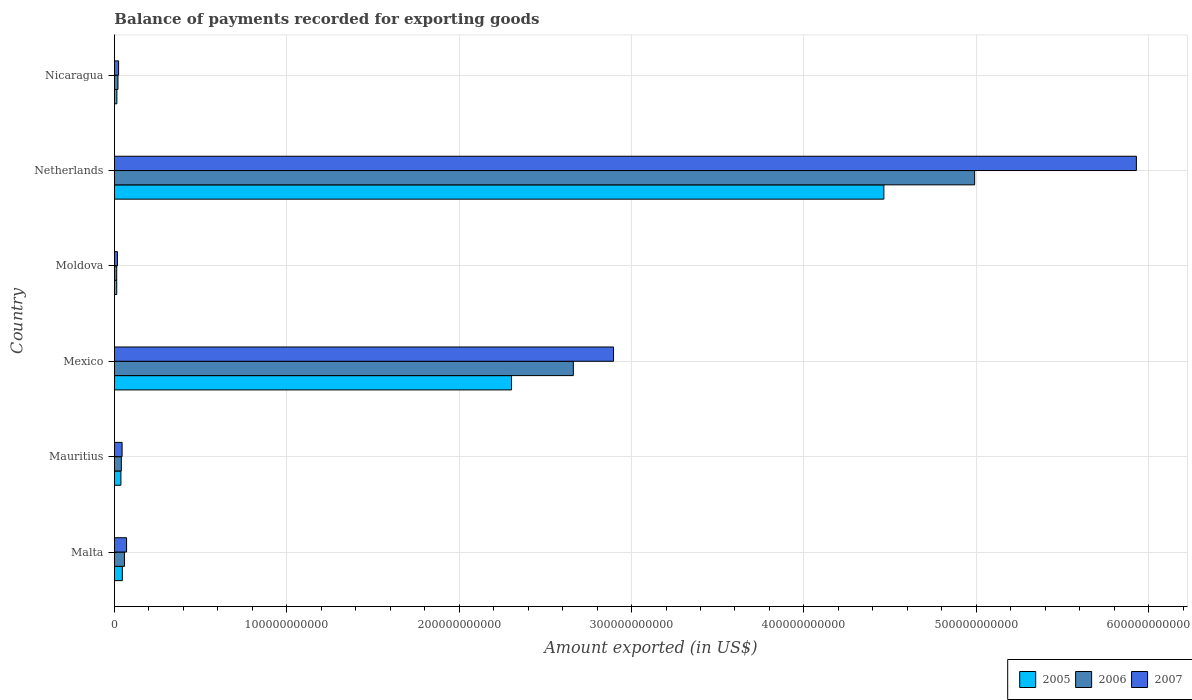How many different coloured bars are there?
Make the answer very short. 3. How many groups of bars are there?
Give a very brief answer. 6. Are the number of bars per tick equal to the number of legend labels?
Make the answer very short. Yes. Are the number of bars on each tick of the Y-axis equal?
Your response must be concise. Yes. How many bars are there on the 5th tick from the bottom?
Provide a short and direct response. 3. What is the label of the 6th group of bars from the top?
Your answer should be very brief. Malta. In how many cases, is the number of bars for a given country not equal to the number of legend labels?
Ensure brevity in your answer.  0. What is the amount exported in 2005 in Moldova?
Your answer should be very brief. 1.33e+09. Across all countries, what is the maximum amount exported in 2007?
Your answer should be compact. 5.93e+11. Across all countries, what is the minimum amount exported in 2007?
Your response must be concise. 1.75e+09. In which country was the amount exported in 2005 maximum?
Provide a succinct answer. Netherlands. In which country was the amount exported in 2007 minimum?
Your answer should be very brief. Moldova. What is the total amount exported in 2005 in the graph?
Your response must be concise. 6.88e+11. What is the difference between the amount exported in 2006 in Malta and that in Mauritius?
Your response must be concise. 1.81e+09. What is the difference between the amount exported in 2006 in Netherlands and the amount exported in 2005 in Malta?
Make the answer very short. 4.94e+11. What is the average amount exported in 2005 per country?
Offer a very short reply. 1.15e+11. What is the difference between the amount exported in 2007 and amount exported in 2006 in Mauritius?
Make the answer very short. 4.43e+08. What is the ratio of the amount exported in 2006 in Malta to that in Moldova?
Your answer should be compact. 4.4. What is the difference between the highest and the second highest amount exported in 2006?
Offer a very short reply. 2.33e+11. What is the difference between the highest and the lowest amount exported in 2005?
Your answer should be very brief. 4.45e+11. How many bars are there?
Provide a succinct answer. 18. What is the difference between two consecutive major ticks on the X-axis?
Your answer should be very brief. 1.00e+11. Does the graph contain grids?
Offer a terse response. Yes. Where does the legend appear in the graph?
Offer a very short reply. Bottom right. How are the legend labels stacked?
Make the answer very short. Horizontal. What is the title of the graph?
Your answer should be compact. Balance of payments recorded for exporting goods. What is the label or title of the X-axis?
Offer a terse response. Amount exported (in US$). What is the Amount exported (in US$) of 2005 in Malta?
Your response must be concise. 4.59e+09. What is the Amount exported (in US$) in 2006 in Malta?
Make the answer very short. 5.81e+09. What is the Amount exported (in US$) of 2007 in Malta?
Provide a succinct answer. 7.05e+09. What is the Amount exported (in US$) in 2005 in Mauritius?
Ensure brevity in your answer.  3.76e+09. What is the Amount exported (in US$) of 2006 in Mauritius?
Your response must be concise. 4.00e+09. What is the Amount exported (in US$) in 2007 in Mauritius?
Keep it short and to the point. 4.44e+09. What is the Amount exported (in US$) in 2005 in Mexico?
Your answer should be very brief. 2.30e+11. What is the Amount exported (in US$) in 2006 in Mexico?
Offer a very short reply. 2.66e+11. What is the Amount exported (in US$) in 2007 in Mexico?
Provide a succinct answer. 2.90e+11. What is the Amount exported (in US$) of 2005 in Moldova?
Provide a short and direct response. 1.33e+09. What is the Amount exported (in US$) in 2006 in Moldova?
Your response must be concise. 1.32e+09. What is the Amount exported (in US$) in 2007 in Moldova?
Offer a very short reply. 1.75e+09. What is the Amount exported (in US$) in 2005 in Netherlands?
Give a very brief answer. 4.46e+11. What is the Amount exported (in US$) of 2006 in Netherlands?
Offer a very short reply. 4.99e+11. What is the Amount exported (in US$) of 2007 in Netherlands?
Your answer should be compact. 5.93e+11. What is the Amount exported (in US$) of 2005 in Nicaragua?
Keep it short and to the point. 1.41e+09. What is the Amount exported (in US$) in 2006 in Nicaragua?
Your answer should be very brief. 2.05e+09. What is the Amount exported (in US$) of 2007 in Nicaragua?
Your answer should be compact. 2.42e+09. Across all countries, what is the maximum Amount exported (in US$) in 2005?
Provide a short and direct response. 4.46e+11. Across all countries, what is the maximum Amount exported (in US$) of 2006?
Your answer should be very brief. 4.99e+11. Across all countries, what is the maximum Amount exported (in US$) of 2007?
Give a very brief answer. 5.93e+11. Across all countries, what is the minimum Amount exported (in US$) of 2005?
Your answer should be compact. 1.33e+09. Across all countries, what is the minimum Amount exported (in US$) of 2006?
Provide a short and direct response. 1.32e+09. Across all countries, what is the minimum Amount exported (in US$) of 2007?
Keep it short and to the point. 1.75e+09. What is the total Amount exported (in US$) in 2005 in the graph?
Keep it short and to the point. 6.88e+11. What is the total Amount exported (in US$) of 2006 in the graph?
Ensure brevity in your answer.  7.78e+11. What is the total Amount exported (in US$) of 2007 in the graph?
Your answer should be compact. 8.98e+11. What is the difference between the Amount exported (in US$) of 2005 in Malta and that in Mauritius?
Offer a terse response. 8.36e+08. What is the difference between the Amount exported (in US$) in 2006 in Malta and that in Mauritius?
Your answer should be very brief. 1.81e+09. What is the difference between the Amount exported (in US$) of 2007 in Malta and that in Mauritius?
Your response must be concise. 2.61e+09. What is the difference between the Amount exported (in US$) of 2005 in Malta and that in Mexico?
Make the answer very short. -2.26e+11. What is the difference between the Amount exported (in US$) in 2006 in Malta and that in Mexico?
Ensure brevity in your answer.  -2.60e+11. What is the difference between the Amount exported (in US$) of 2007 in Malta and that in Mexico?
Your response must be concise. -2.82e+11. What is the difference between the Amount exported (in US$) of 2005 in Malta and that in Moldova?
Make the answer very short. 3.26e+09. What is the difference between the Amount exported (in US$) in 2006 in Malta and that in Moldova?
Give a very brief answer. 4.49e+09. What is the difference between the Amount exported (in US$) in 2007 in Malta and that in Moldova?
Provide a short and direct response. 5.30e+09. What is the difference between the Amount exported (in US$) of 2005 in Malta and that in Netherlands?
Your response must be concise. -4.42e+11. What is the difference between the Amount exported (in US$) of 2006 in Malta and that in Netherlands?
Give a very brief answer. -4.93e+11. What is the difference between the Amount exported (in US$) in 2007 in Malta and that in Netherlands?
Your answer should be very brief. -5.86e+11. What is the difference between the Amount exported (in US$) of 2005 in Malta and that in Nicaragua?
Provide a short and direct response. 3.18e+09. What is the difference between the Amount exported (in US$) in 2006 in Malta and that in Nicaragua?
Give a very brief answer. 3.76e+09. What is the difference between the Amount exported (in US$) in 2007 in Malta and that in Nicaragua?
Your response must be concise. 4.63e+09. What is the difference between the Amount exported (in US$) in 2005 in Mauritius and that in Mexico?
Give a very brief answer. -2.27e+11. What is the difference between the Amount exported (in US$) in 2006 in Mauritius and that in Mexico?
Offer a very short reply. -2.62e+11. What is the difference between the Amount exported (in US$) of 2007 in Mauritius and that in Mexico?
Keep it short and to the point. -2.85e+11. What is the difference between the Amount exported (in US$) of 2005 in Mauritius and that in Moldova?
Offer a very short reply. 2.42e+09. What is the difference between the Amount exported (in US$) of 2006 in Mauritius and that in Moldova?
Ensure brevity in your answer.  2.68e+09. What is the difference between the Amount exported (in US$) of 2007 in Mauritius and that in Moldova?
Offer a very short reply. 2.70e+09. What is the difference between the Amount exported (in US$) of 2005 in Mauritius and that in Netherlands?
Provide a short and direct response. -4.43e+11. What is the difference between the Amount exported (in US$) in 2006 in Mauritius and that in Netherlands?
Give a very brief answer. -4.95e+11. What is the difference between the Amount exported (in US$) of 2007 in Mauritius and that in Netherlands?
Provide a succinct answer. -5.88e+11. What is the difference between the Amount exported (in US$) in 2005 in Mauritius and that in Nicaragua?
Keep it short and to the point. 2.35e+09. What is the difference between the Amount exported (in US$) of 2006 in Mauritius and that in Nicaragua?
Provide a short and direct response. 1.95e+09. What is the difference between the Amount exported (in US$) in 2007 in Mauritius and that in Nicaragua?
Make the answer very short. 2.02e+09. What is the difference between the Amount exported (in US$) in 2005 in Mexico and that in Moldova?
Provide a succinct answer. 2.29e+11. What is the difference between the Amount exported (in US$) of 2006 in Mexico and that in Moldova?
Your response must be concise. 2.65e+11. What is the difference between the Amount exported (in US$) of 2007 in Mexico and that in Moldova?
Provide a succinct answer. 2.88e+11. What is the difference between the Amount exported (in US$) in 2005 in Mexico and that in Netherlands?
Your response must be concise. -2.16e+11. What is the difference between the Amount exported (in US$) in 2006 in Mexico and that in Netherlands?
Your answer should be compact. -2.33e+11. What is the difference between the Amount exported (in US$) of 2007 in Mexico and that in Netherlands?
Keep it short and to the point. -3.03e+11. What is the difference between the Amount exported (in US$) in 2005 in Mexico and that in Nicaragua?
Ensure brevity in your answer.  2.29e+11. What is the difference between the Amount exported (in US$) in 2006 in Mexico and that in Nicaragua?
Keep it short and to the point. 2.64e+11. What is the difference between the Amount exported (in US$) in 2007 in Mexico and that in Nicaragua?
Provide a short and direct response. 2.87e+11. What is the difference between the Amount exported (in US$) of 2005 in Moldova and that in Netherlands?
Ensure brevity in your answer.  -4.45e+11. What is the difference between the Amount exported (in US$) in 2006 in Moldova and that in Netherlands?
Your answer should be compact. -4.98e+11. What is the difference between the Amount exported (in US$) in 2007 in Moldova and that in Netherlands?
Your response must be concise. -5.91e+11. What is the difference between the Amount exported (in US$) in 2005 in Moldova and that in Nicaragua?
Your response must be concise. -7.89e+07. What is the difference between the Amount exported (in US$) of 2006 in Moldova and that in Nicaragua?
Provide a short and direct response. -7.32e+08. What is the difference between the Amount exported (in US$) in 2007 in Moldova and that in Nicaragua?
Your answer should be very brief. -6.74e+08. What is the difference between the Amount exported (in US$) of 2005 in Netherlands and that in Nicaragua?
Keep it short and to the point. 4.45e+11. What is the difference between the Amount exported (in US$) of 2006 in Netherlands and that in Nicaragua?
Your response must be concise. 4.97e+11. What is the difference between the Amount exported (in US$) of 2007 in Netherlands and that in Nicaragua?
Your answer should be compact. 5.90e+11. What is the difference between the Amount exported (in US$) of 2005 in Malta and the Amount exported (in US$) of 2006 in Mauritius?
Your answer should be compact. 5.92e+08. What is the difference between the Amount exported (in US$) in 2005 in Malta and the Amount exported (in US$) in 2007 in Mauritius?
Ensure brevity in your answer.  1.49e+08. What is the difference between the Amount exported (in US$) of 2006 in Malta and the Amount exported (in US$) of 2007 in Mauritius?
Your answer should be very brief. 1.37e+09. What is the difference between the Amount exported (in US$) of 2005 in Malta and the Amount exported (in US$) of 2006 in Mexico?
Your answer should be very brief. -2.62e+11. What is the difference between the Amount exported (in US$) of 2005 in Malta and the Amount exported (in US$) of 2007 in Mexico?
Your answer should be very brief. -2.85e+11. What is the difference between the Amount exported (in US$) of 2006 in Malta and the Amount exported (in US$) of 2007 in Mexico?
Make the answer very short. -2.84e+11. What is the difference between the Amount exported (in US$) of 2005 in Malta and the Amount exported (in US$) of 2006 in Moldova?
Keep it short and to the point. 3.27e+09. What is the difference between the Amount exported (in US$) of 2005 in Malta and the Amount exported (in US$) of 2007 in Moldova?
Your answer should be very brief. 2.85e+09. What is the difference between the Amount exported (in US$) in 2006 in Malta and the Amount exported (in US$) in 2007 in Moldova?
Offer a terse response. 4.07e+09. What is the difference between the Amount exported (in US$) of 2005 in Malta and the Amount exported (in US$) of 2006 in Netherlands?
Provide a succinct answer. -4.94e+11. What is the difference between the Amount exported (in US$) of 2005 in Malta and the Amount exported (in US$) of 2007 in Netherlands?
Make the answer very short. -5.88e+11. What is the difference between the Amount exported (in US$) in 2006 in Malta and the Amount exported (in US$) in 2007 in Netherlands?
Give a very brief answer. -5.87e+11. What is the difference between the Amount exported (in US$) of 2005 in Malta and the Amount exported (in US$) of 2006 in Nicaragua?
Offer a terse response. 2.54e+09. What is the difference between the Amount exported (in US$) in 2005 in Malta and the Amount exported (in US$) in 2007 in Nicaragua?
Give a very brief answer. 2.17e+09. What is the difference between the Amount exported (in US$) in 2006 in Malta and the Amount exported (in US$) in 2007 in Nicaragua?
Ensure brevity in your answer.  3.39e+09. What is the difference between the Amount exported (in US$) of 2005 in Mauritius and the Amount exported (in US$) of 2006 in Mexico?
Offer a terse response. -2.62e+11. What is the difference between the Amount exported (in US$) in 2005 in Mauritius and the Amount exported (in US$) in 2007 in Mexico?
Your answer should be compact. -2.86e+11. What is the difference between the Amount exported (in US$) in 2006 in Mauritius and the Amount exported (in US$) in 2007 in Mexico?
Make the answer very short. -2.86e+11. What is the difference between the Amount exported (in US$) of 2005 in Mauritius and the Amount exported (in US$) of 2006 in Moldova?
Keep it short and to the point. 2.43e+09. What is the difference between the Amount exported (in US$) in 2005 in Mauritius and the Amount exported (in US$) in 2007 in Moldova?
Offer a very short reply. 2.01e+09. What is the difference between the Amount exported (in US$) of 2006 in Mauritius and the Amount exported (in US$) of 2007 in Moldova?
Your response must be concise. 2.25e+09. What is the difference between the Amount exported (in US$) in 2005 in Mauritius and the Amount exported (in US$) in 2006 in Netherlands?
Your answer should be compact. -4.95e+11. What is the difference between the Amount exported (in US$) in 2005 in Mauritius and the Amount exported (in US$) in 2007 in Netherlands?
Make the answer very short. -5.89e+11. What is the difference between the Amount exported (in US$) of 2006 in Mauritius and the Amount exported (in US$) of 2007 in Netherlands?
Give a very brief answer. -5.89e+11. What is the difference between the Amount exported (in US$) of 2005 in Mauritius and the Amount exported (in US$) of 2006 in Nicaragua?
Keep it short and to the point. 1.70e+09. What is the difference between the Amount exported (in US$) of 2005 in Mauritius and the Amount exported (in US$) of 2007 in Nicaragua?
Ensure brevity in your answer.  1.34e+09. What is the difference between the Amount exported (in US$) in 2006 in Mauritius and the Amount exported (in US$) in 2007 in Nicaragua?
Your answer should be very brief. 1.58e+09. What is the difference between the Amount exported (in US$) in 2005 in Mexico and the Amount exported (in US$) in 2006 in Moldova?
Your answer should be compact. 2.29e+11. What is the difference between the Amount exported (in US$) of 2005 in Mexico and the Amount exported (in US$) of 2007 in Moldova?
Offer a very short reply. 2.29e+11. What is the difference between the Amount exported (in US$) of 2006 in Mexico and the Amount exported (in US$) of 2007 in Moldova?
Your response must be concise. 2.64e+11. What is the difference between the Amount exported (in US$) of 2005 in Mexico and the Amount exported (in US$) of 2006 in Netherlands?
Offer a very short reply. -2.69e+11. What is the difference between the Amount exported (in US$) in 2005 in Mexico and the Amount exported (in US$) in 2007 in Netherlands?
Provide a succinct answer. -3.62e+11. What is the difference between the Amount exported (in US$) of 2006 in Mexico and the Amount exported (in US$) of 2007 in Netherlands?
Offer a terse response. -3.27e+11. What is the difference between the Amount exported (in US$) of 2005 in Mexico and the Amount exported (in US$) of 2006 in Nicaragua?
Make the answer very short. 2.28e+11. What is the difference between the Amount exported (in US$) in 2005 in Mexico and the Amount exported (in US$) in 2007 in Nicaragua?
Provide a succinct answer. 2.28e+11. What is the difference between the Amount exported (in US$) in 2006 in Mexico and the Amount exported (in US$) in 2007 in Nicaragua?
Your response must be concise. 2.64e+11. What is the difference between the Amount exported (in US$) of 2005 in Moldova and the Amount exported (in US$) of 2006 in Netherlands?
Your response must be concise. -4.98e+11. What is the difference between the Amount exported (in US$) in 2005 in Moldova and the Amount exported (in US$) in 2007 in Netherlands?
Make the answer very short. -5.92e+11. What is the difference between the Amount exported (in US$) of 2006 in Moldova and the Amount exported (in US$) of 2007 in Netherlands?
Give a very brief answer. -5.92e+11. What is the difference between the Amount exported (in US$) in 2005 in Moldova and the Amount exported (in US$) in 2006 in Nicaragua?
Provide a short and direct response. -7.22e+08. What is the difference between the Amount exported (in US$) in 2005 in Moldova and the Amount exported (in US$) in 2007 in Nicaragua?
Keep it short and to the point. -1.09e+09. What is the difference between the Amount exported (in US$) in 2006 in Moldova and the Amount exported (in US$) in 2007 in Nicaragua?
Give a very brief answer. -1.10e+09. What is the difference between the Amount exported (in US$) in 2005 in Netherlands and the Amount exported (in US$) in 2006 in Nicaragua?
Keep it short and to the point. 4.44e+11. What is the difference between the Amount exported (in US$) in 2005 in Netherlands and the Amount exported (in US$) in 2007 in Nicaragua?
Provide a succinct answer. 4.44e+11. What is the difference between the Amount exported (in US$) of 2006 in Netherlands and the Amount exported (in US$) of 2007 in Nicaragua?
Your answer should be compact. 4.97e+11. What is the average Amount exported (in US$) of 2005 per country?
Your answer should be very brief. 1.15e+11. What is the average Amount exported (in US$) of 2006 per country?
Provide a short and direct response. 1.30e+11. What is the average Amount exported (in US$) in 2007 per country?
Your response must be concise. 1.50e+11. What is the difference between the Amount exported (in US$) of 2005 and Amount exported (in US$) of 2006 in Malta?
Your response must be concise. -1.22e+09. What is the difference between the Amount exported (in US$) of 2005 and Amount exported (in US$) of 2007 in Malta?
Your response must be concise. -2.46e+09. What is the difference between the Amount exported (in US$) in 2006 and Amount exported (in US$) in 2007 in Malta?
Give a very brief answer. -1.24e+09. What is the difference between the Amount exported (in US$) of 2005 and Amount exported (in US$) of 2006 in Mauritius?
Offer a very short reply. -2.44e+08. What is the difference between the Amount exported (in US$) of 2005 and Amount exported (in US$) of 2007 in Mauritius?
Your answer should be very brief. -6.87e+08. What is the difference between the Amount exported (in US$) of 2006 and Amount exported (in US$) of 2007 in Mauritius?
Offer a very short reply. -4.43e+08. What is the difference between the Amount exported (in US$) of 2005 and Amount exported (in US$) of 2006 in Mexico?
Offer a terse response. -3.59e+1. What is the difference between the Amount exported (in US$) in 2005 and Amount exported (in US$) in 2007 in Mexico?
Keep it short and to the point. -5.92e+1. What is the difference between the Amount exported (in US$) in 2006 and Amount exported (in US$) in 2007 in Mexico?
Keep it short and to the point. -2.33e+1. What is the difference between the Amount exported (in US$) in 2005 and Amount exported (in US$) in 2006 in Moldova?
Give a very brief answer. 1.02e+07. What is the difference between the Amount exported (in US$) of 2005 and Amount exported (in US$) of 2007 in Moldova?
Your answer should be very brief. -4.13e+08. What is the difference between the Amount exported (in US$) in 2006 and Amount exported (in US$) in 2007 in Moldova?
Provide a short and direct response. -4.23e+08. What is the difference between the Amount exported (in US$) of 2005 and Amount exported (in US$) of 2006 in Netherlands?
Ensure brevity in your answer.  -5.27e+1. What is the difference between the Amount exported (in US$) in 2005 and Amount exported (in US$) in 2007 in Netherlands?
Provide a succinct answer. -1.46e+11. What is the difference between the Amount exported (in US$) in 2006 and Amount exported (in US$) in 2007 in Netherlands?
Make the answer very short. -9.38e+1. What is the difference between the Amount exported (in US$) in 2005 and Amount exported (in US$) in 2006 in Nicaragua?
Your answer should be very brief. -6.43e+08. What is the difference between the Amount exported (in US$) of 2005 and Amount exported (in US$) of 2007 in Nicaragua?
Ensure brevity in your answer.  -1.01e+09. What is the difference between the Amount exported (in US$) of 2006 and Amount exported (in US$) of 2007 in Nicaragua?
Give a very brief answer. -3.66e+08. What is the ratio of the Amount exported (in US$) of 2005 in Malta to that in Mauritius?
Provide a succinct answer. 1.22. What is the ratio of the Amount exported (in US$) of 2006 in Malta to that in Mauritius?
Your answer should be compact. 1.45. What is the ratio of the Amount exported (in US$) of 2007 in Malta to that in Mauritius?
Offer a very short reply. 1.59. What is the ratio of the Amount exported (in US$) of 2005 in Malta to that in Mexico?
Your response must be concise. 0.02. What is the ratio of the Amount exported (in US$) of 2006 in Malta to that in Mexico?
Ensure brevity in your answer.  0.02. What is the ratio of the Amount exported (in US$) of 2007 in Malta to that in Mexico?
Your response must be concise. 0.02. What is the ratio of the Amount exported (in US$) of 2005 in Malta to that in Moldova?
Offer a very short reply. 3.45. What is the ratio of the Amount exported (in US$) of 2006 in Malta to that in Moldova?
Provide a short and direct response. 4.4. What is the ratio of the Amount exported (in US$) of 2007 in Malta to that in Moldova?
Your answer should be compact. 4.04. What is the ratio of the Amount exported (in US$) in 2005 in Malta to that in Netherlands?
Ensure brevity in your answer.  0.01. What is the ratio of the Amount exported (in US$) of 2006 in Malta to that in Netherlands?
Your answer should be very brief. 0.01. What is the ratio of the Amount exported (in US$) in 2007 in Malta to that in Netherlands?
Your response must be concise. 0.01. What is the ratio of the Amount exported (in US$) in 2005 in Malta to that in Nicaragua?
Your response must be concise. 3.25. What is the ratio of the Amount exported (in US$) of 2006 in Malta to that in Nicaragua?
Ensure brevity in your answer.  2.83. What is the ratio of the Amount exported (in US$) of 2007 in Malta to that in Nicaragua?
Keep it short and to the point. 2.91. What is the ratio of the Amount exported (in US$) in 2005 in Mauritius to that in Mexico?
Ensure brevity in your answer.  0.02. What is the ratio of the Amount exported (in US$) of 2006 in Mauritius to that in Mexico?
Offer a very short reply. 0.01. What is the ratio of the Amount exported (in US$) of 2007 in Mauritius to that in Mexico?
Keep it short and to the point. 0.02. What is the ratio of the Amount exported (in US$) in 2005 in Mauritius to that in Moldova?
Your answer should be compact. 2.82. What is the ratio of the Amount exported (in US$) in 2006 in Mauritius to that in Moldova?
Your answer should be very brief. 3.03. What is the ratio of the Amount exported (in US$) of 2007 in Mauritius to that in Moldova?
Offer a very short reply. 2.55. What is the ratio of the Amount exported (in US$) in 2005 in Mauritius to that in Netherlands?
Offer a very short reply. 0.01. What is the ratio of the Amount exported (in US$) in 2006 in Mauritius to that in Netherlands?
Keep it short and to the point. 0.01. What is the ratio of the Amount exported (in US$) in 2007 in Mauritius to that in Netherlands?
Your answer should be compact. 0.01. What is the ratio of the Amount exported (in US$) of 2005 in Mauritius to that in Nicaragua?
Offer a terse response. 2.66. What is the ratio of the Amount exported (in US$) of 2006 in Mauritius to that in Nicaragua?
Give a very brief answer. 1.95. What is the ratio of the Amount exported (in US$) of 2007 in Mauritius to that in Nicaragua?
Keep it short and to the point. 1.84. What is the ratio of the Amount exported (in US$) of 2005 in Mexico to that in Moldova?
Provide a succinct answer. 172.92. What is the ratio of the Amount exported (in US$) of 2006 in Mexico to that in Moldova?
Keep it short and to the point. 201.37. What is the ratio of the Amount exported (in US$) in 2007 in Mexico to that in Moldova?
Give a very brief answer. 165.88. What is the ratio of the Amount exported (in US$) of 2005 in Mexico to that in Netherlands?
Keep it short and to the point. 0.52. What is the ratio of the Amount exported (in US$) of 2006 in Mexico to that in Netherlands?
Provide a succinct answer. 0.53. What is the ratio of the Amount exported (in US$) in 2007 in Mexico to that in Netherlands?
Provide a short and direct response. 0.49. What is the ratio of the Amount exported (in US$) of 2005 in Mexico to that in Nicaragua?
Give a very brief answer. 163.25. What is the ratio of the Amount exported (in US$) of 2006 in Mexico to that in Nicaragua?
Offer a very short reply. 129.61. What is the ratio of the Amount exported (in US$) in 2007 in Mexico to that in Nicaragua?
Give a very brief answer. 119.67. What is the ratio of the Amount exported (in US$) of 2005 in Moldova to that in Netherlands?
Offer a terse response. 0. What is the ratio of the Amount exported (in US$) of 2006 in Moldova to that in Netherlands?
Your answer should be very brief. 0. What is the ratio of the Amount exported (in US$) in 2007 in Moldova to that in Netherlands?
Offer a terse response. 0. What is the ratio of the Amount exported (in US$) in 2005 in Moldova to that in Nicaragua?
Provide a succinct answer. 0.94. What is the ratio of the Amount exported (in US$) of 2006 in Moldova to that in Nicaragua?
Your answer should be very brief. 0.64. What is the ratio of the Amount exported (in US$) in 2007 in Moldova to that in Nicaragua?
Your answer should be very brief. 0.72. What is the ratio of the Amount exported (in US$) of 2005 in Netherlands to that in Nicaragua?
Make the answer very short. 316.32. What is the ratio of the Amount exported (in US$) in 2006 in Netherlands to that in Nicaragua?
Keep it short and to the point. 242.95. What is the ratio of the Amount exported (in US$) of 2007 in Netherlands to that in Nicaragua?
Your answer should be compact. 245.03. What is the difference between the highest and the second highest Amount exported (in US$) in 2005?
Keep it short and to the point. 2.16e+11. What is the difference between the highest and the second highest Amount exported (in US$) in 2006?
Provide a succinct answer. 2.33e+11. What is the difference between the highest and the second highest Amount exported (in US$) of 2007?
Provide a short and direct response. 3.03e+11. What is the difference between the highest and the lowest Amount exported (in US$) of 2005?
Keep it short and to the point. 4.45e+11. What is the difference between the highest and the lowest Amount exported (in US$) of 2006?
Give a very brief answer. 4.98e+11. What is the difference between the highest and the lowest Amount exported (in US$) in 2007?
Provide a succinct answer. 5.91e+11. 